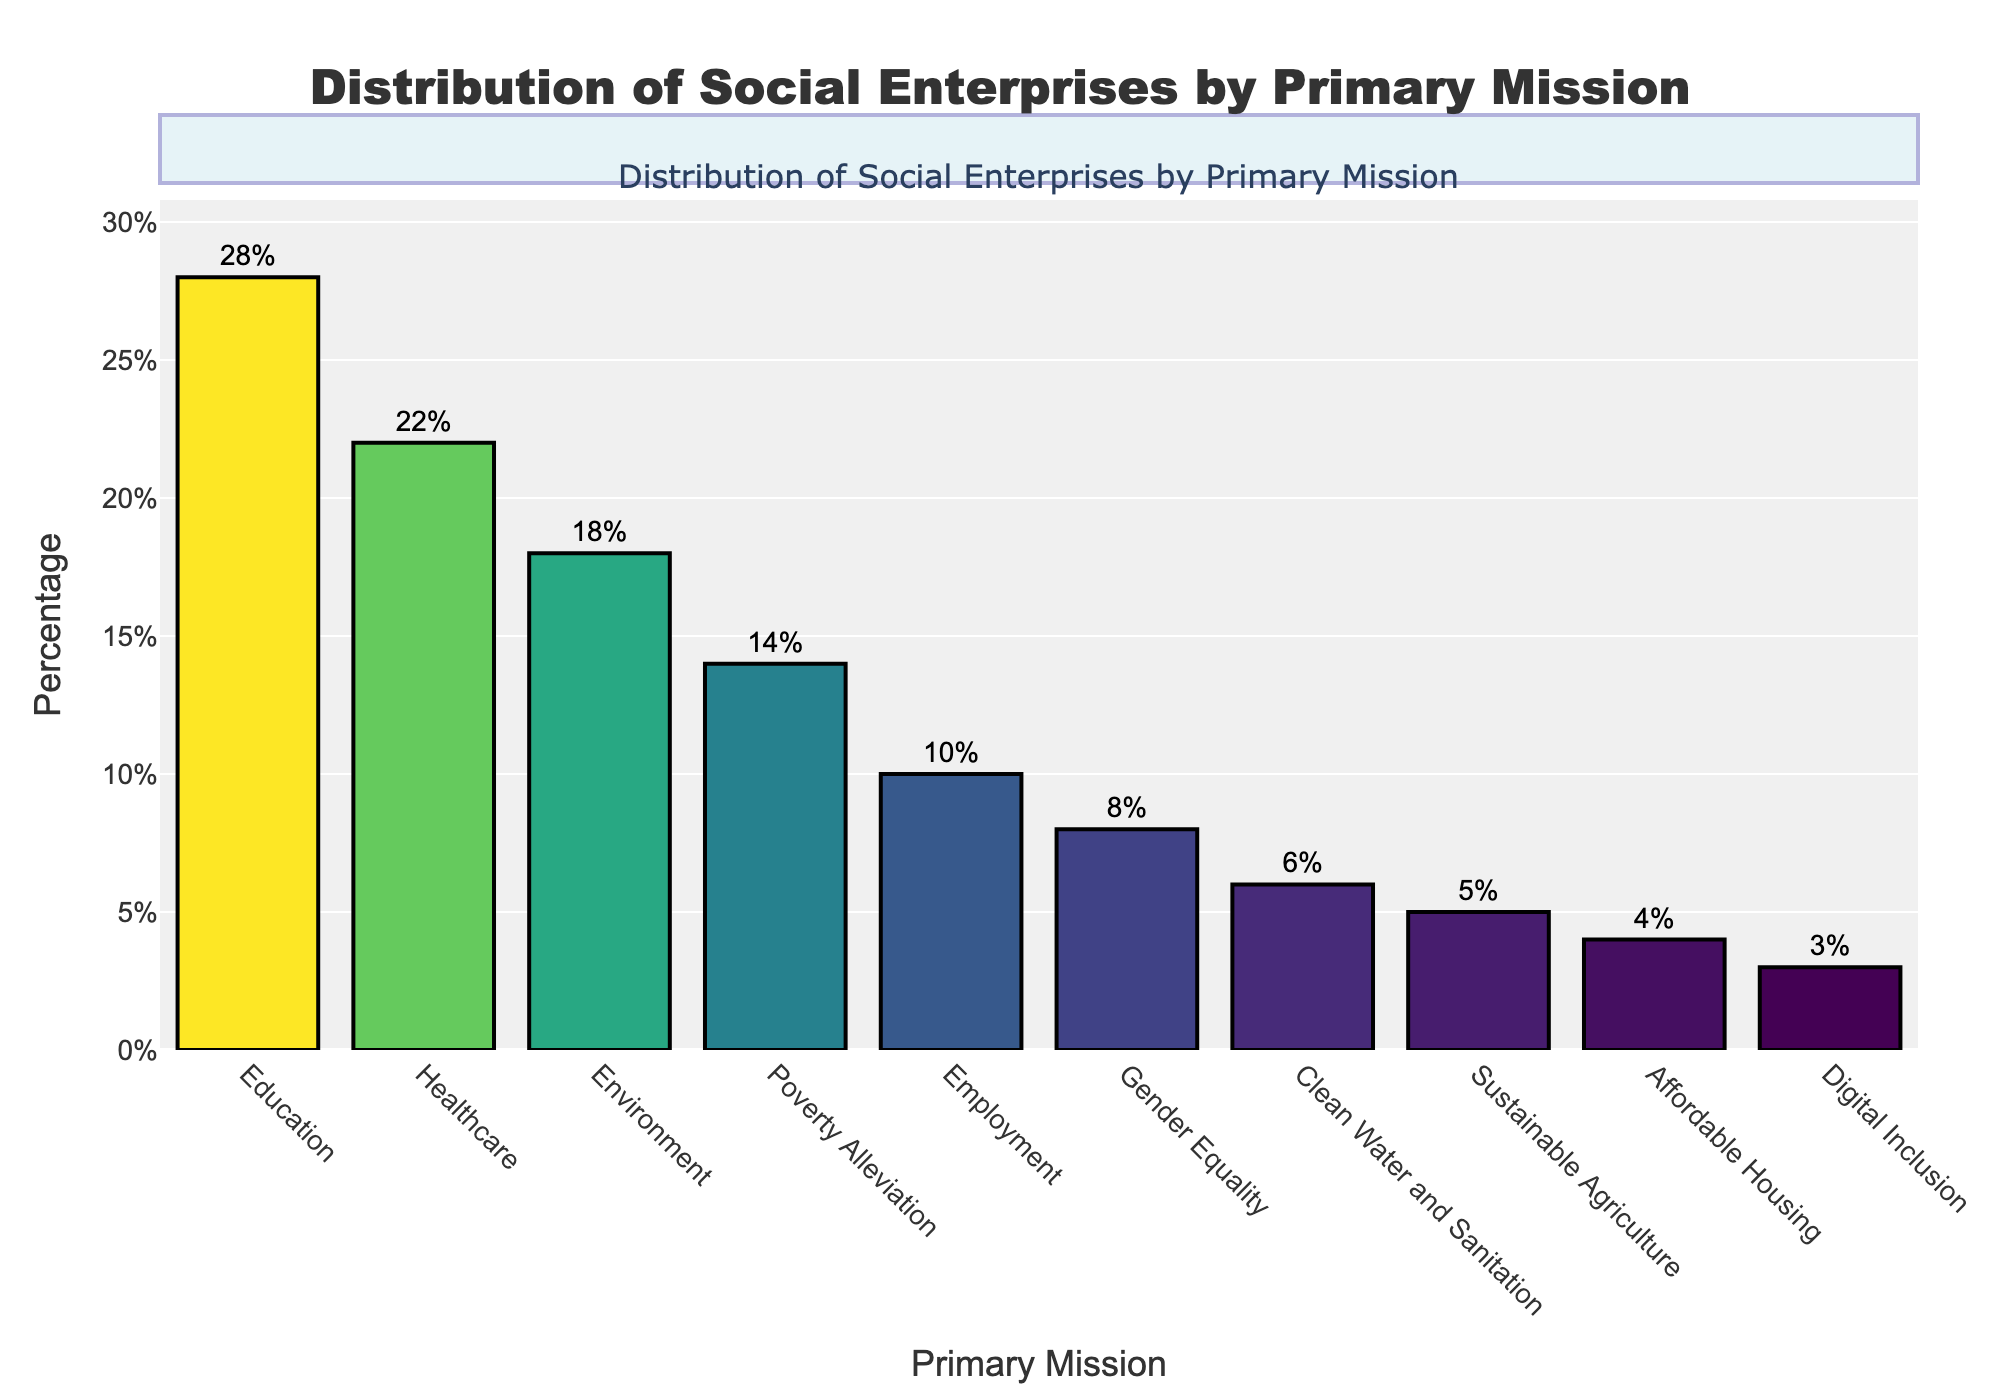Which primary mission has the highest percentage of social enterprises? The highest bar in the chart represents the primary mission with the highest percentage. This bar corresponds to "Education" at 28%.
Answer: Education What is the sum of the percentages for Healthcare and Environment? To find the sum, add the percentage of Healthcare (22%) and Environment (18%). 22 + 18 = 40%
Answer: 40% How much higher is the percentage of social enterprises focused on Education compared to those focused on Employment? Subtract the percentage for Employment (10%) from the percentage for Education (28%). 28 - 10 = 18%
Answer: 18% Which mission has a lower percentage of social enterprises, Gender Equality or Digital Inclusion? Compare the lengths of the bars for Gender Equality (8%) and Digital Inclusion (3%). Digital Inclusion has a shorter bar, indicating a lower percentage.
Answer: Digital Inclusion What is the difference between the highest and lowest percentages? Subtract the lowest percentage (Digital Inclusion at 3%) from the highest percentage (Education at 28%). 28 - 3 = 25%
Answer: 25% Which primary missions have a percentage greater than 15%? Identify the bars with percentages greater than 15%. These are Education (28%), Healthcare (22%), and Environment (18%).
Answer: Education, Healthcare, Environment If you sum the percentages of all primary missions except Education, what is the result? Add the percentages of all missions except Education: 22 + 18 + 14 + 10 + 8 + 6 + 5 + 4 + 3 = 90%.
Answer: 90% What is the ratio of the percentage of social enterprises focused on Poverty Alleviation to those focused on Sustainable Agriculture? Divide the percentage of Poverty Alleviation (14%) by the percentage of Sustainable Agriculture (5%). 14 / 5 = 2.8
Answer: 2.8 Are there more social enterprises focused on Clean Water and Sanitation or Affordable Housing? Compare the lengths of the bars for Clean Water and Sanitation (6%) and Affordable Housing (4%). Clean Water and Sanitation has a higher percentage.
Answer: Clean Water and Sanitation What is the average percentage for the top three primary missions? Calculate the average of the top three percentages: (28 + 22 + 18) / 3 = 68 / 3 ≈ 22.67%
Answer: 22.67% 